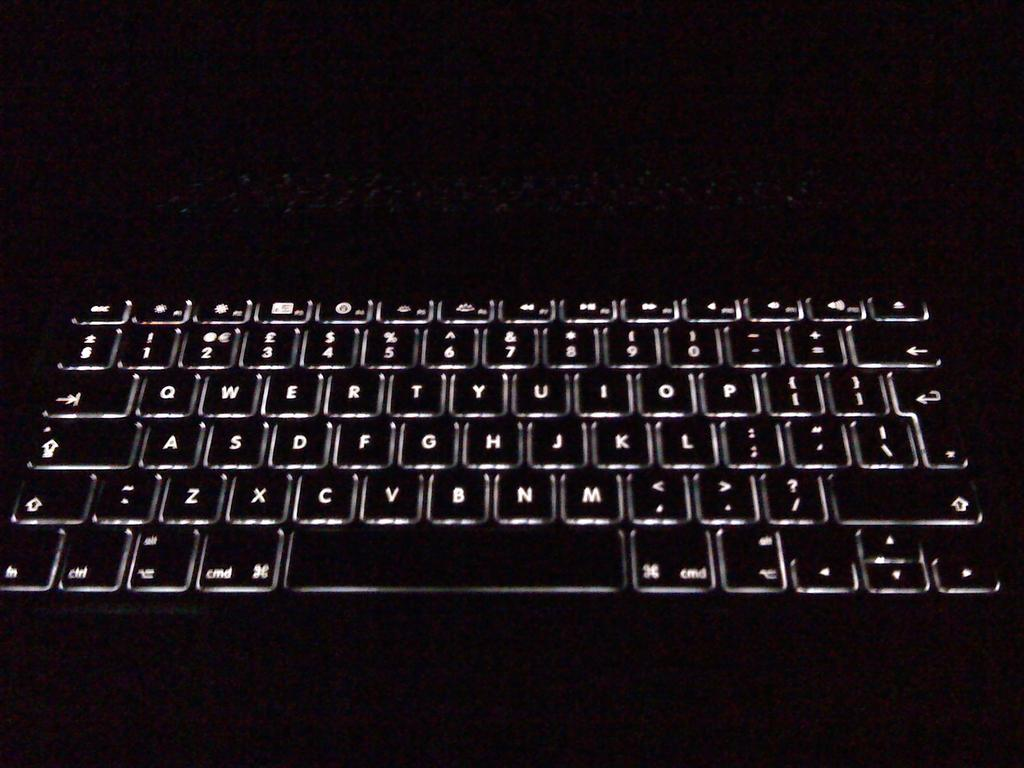<image>
Write a terse but informative summary of the picture. A black keyboard with all the letters showing including cmd on the bottom row. 